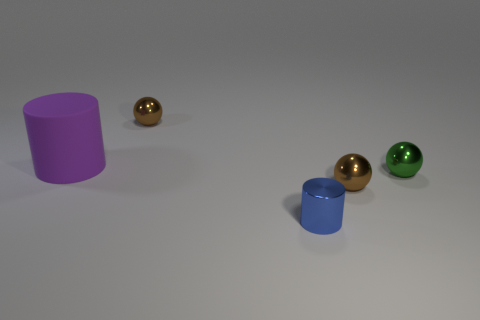Can you tell me the colors of the spheres present? Certainly, there are three spheres present in the image: one is gold-colored, another is also gold but of a slightly different hue, and the third one is green. 